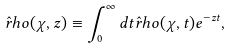<formula> <loc_0><loc_0><loc_500><loc_500>\hat { r } h o ( \chi , z ) \equiv \int _ { 0 } ^ { \infty } d t \hat { r } h o ( \chi , t ) e ^ { - z t } ,</formula> 